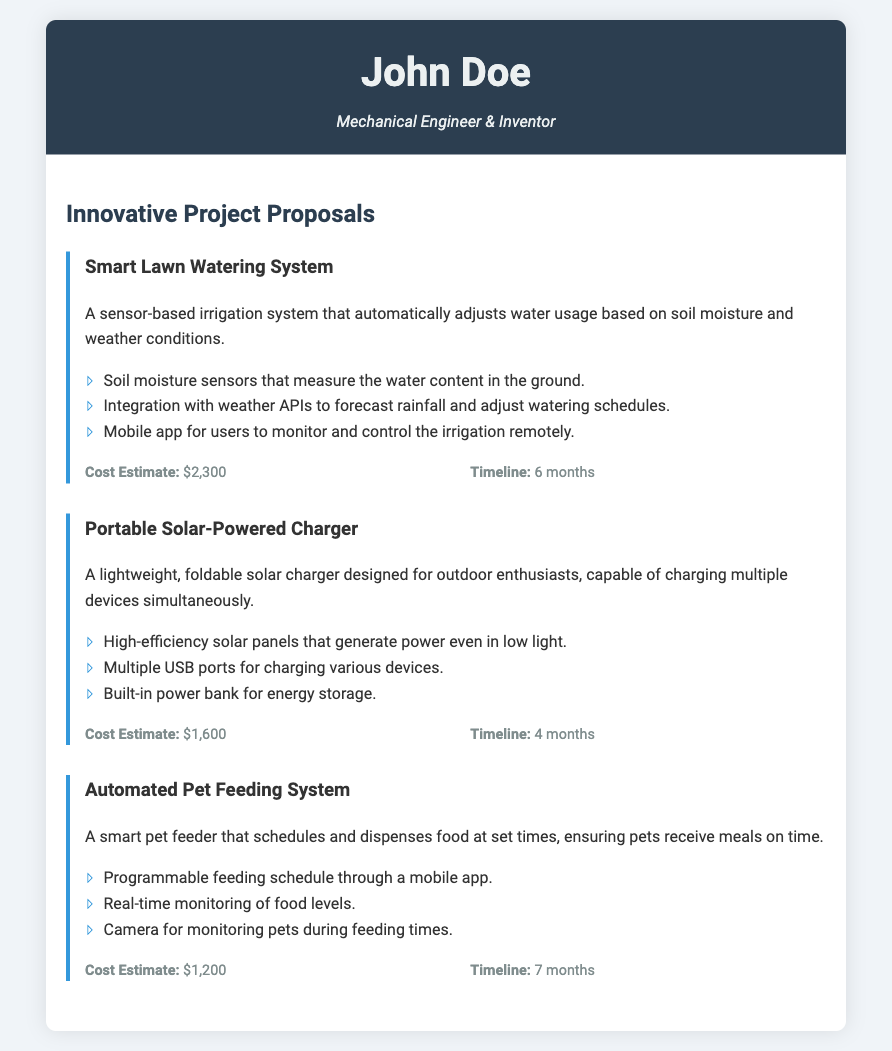what is the name of the first project? The name of the first project is listed at the top of the project section, which is "Smart Lawn Watering System."
Answer: Smart Lawn Watering System what is the cost estimate for the Portable Solar-Powered Charger? The cost estimate for the Portable Solar-Powered Charger is detailed within the project description, stated as "$1,600."
Answer: $1,600 how long will the Automated Pet Feeding System take to develop? The timeline for the Automated Pet Feeding System is mentioned explicitly, which is "7 months."
Answer: 7 months which gadget allows users to monitor feeding times via a camera? This feature is specifically mentioned in the description of the Automated Pet Feeding System.
Answer: Automated Pet Feeding System how many USB ports does the Portable Solar-Powered Charger have? The document states that it has multiple USB ports but does not specify a number. It can be inferred that it is more than one.
Answer: Multiple 